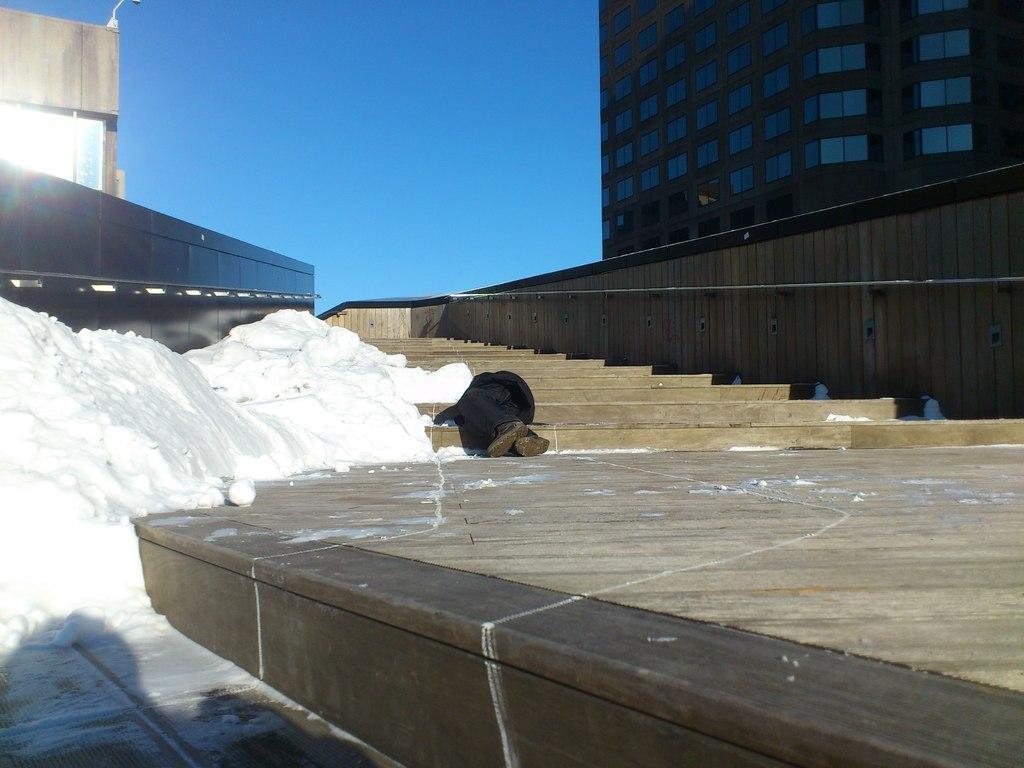How would you summarize this image in a sentence or two? In this picture we can see a person is lying on the steps, in the background we can find few buildings. 